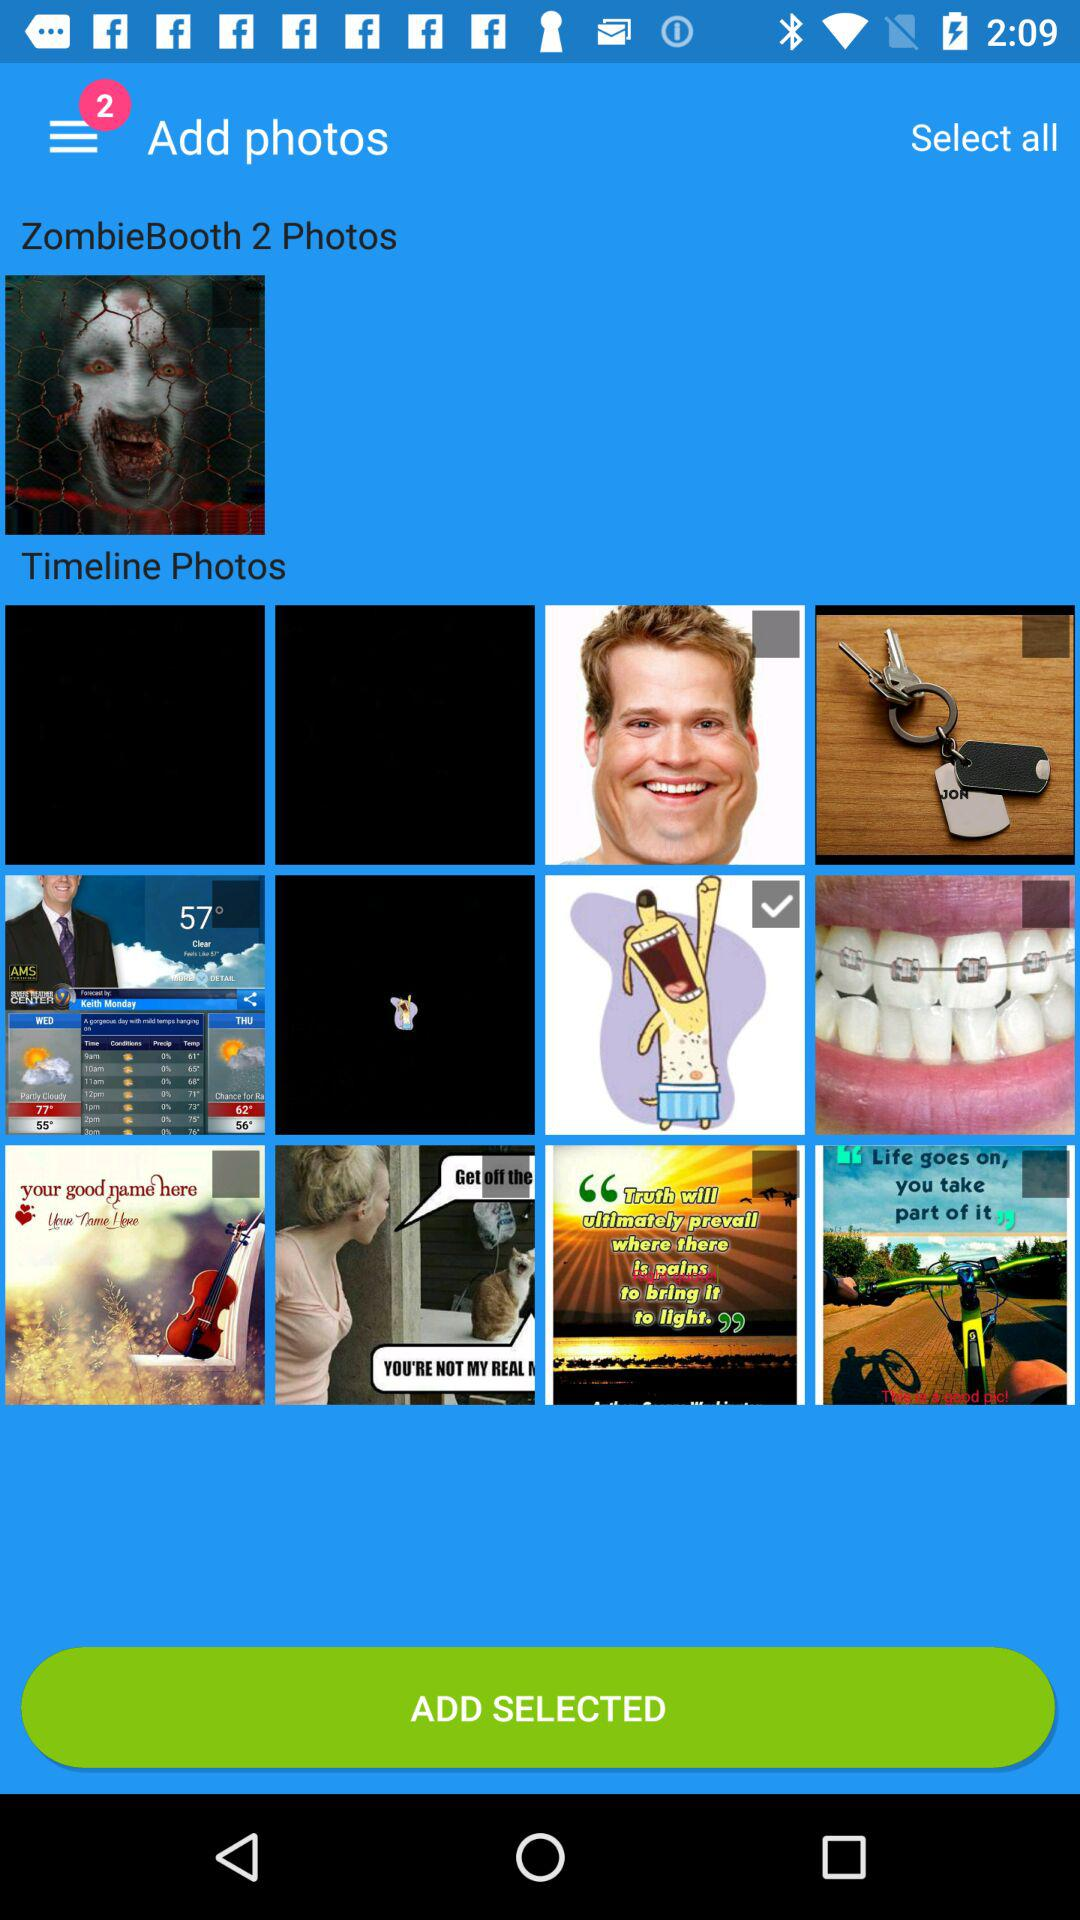How many notifications are in the menu bar? There are 2 notifications in the menu bar. 